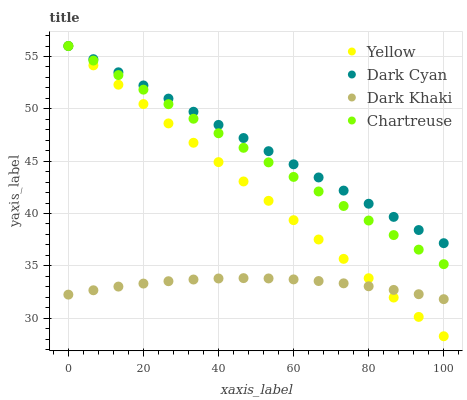Does Dark Khaki have the minimum area under the curve?
Answer yes or no. Yes. Does Dark Cyan have the maximum area under the curve?
Answer yes or no. Yes. Does Chartreuse have the minimum area under the curve?
Answer yes or no. No. Does Chartreuse have the maximum area under the curve?
Answer yes or no. No. Is Chartreuse the smoothest?
Answer yes or no. Yes. Is Dark Khaki the roughest?
Answer yes or no. Yes. Is Dark Khaki the smoothest?
Answer yes or no. No. Is Chartreuse the roughest?
Answer yes or no. No. Does Yellow have the lowest value?
Answer yes or no. Yes. Does Dark Khaki have the lowest value?
Answer yes or no. No. Does Yellow have the highest value?
Answer yes or no. Yes. Does Dark Khaki have the highest value?
Answer yes or no. No. Is Dark Khaki less than Dark Cyan?
Answer yes or no. Yes. Is Chartreuse greater than Dark Khaki?
Answer yes or no. Yes. Does Chartreuse intersect Yellow?
Answer yes or no. Yes. Is Chartreuse less than Yellow?
Answer yes or no. No. Is Chartreuse greater than Yellow?
Answer yes or no. No. Does Dark Khaki intersect Dark Cyan?
Answer yes or no. No. 